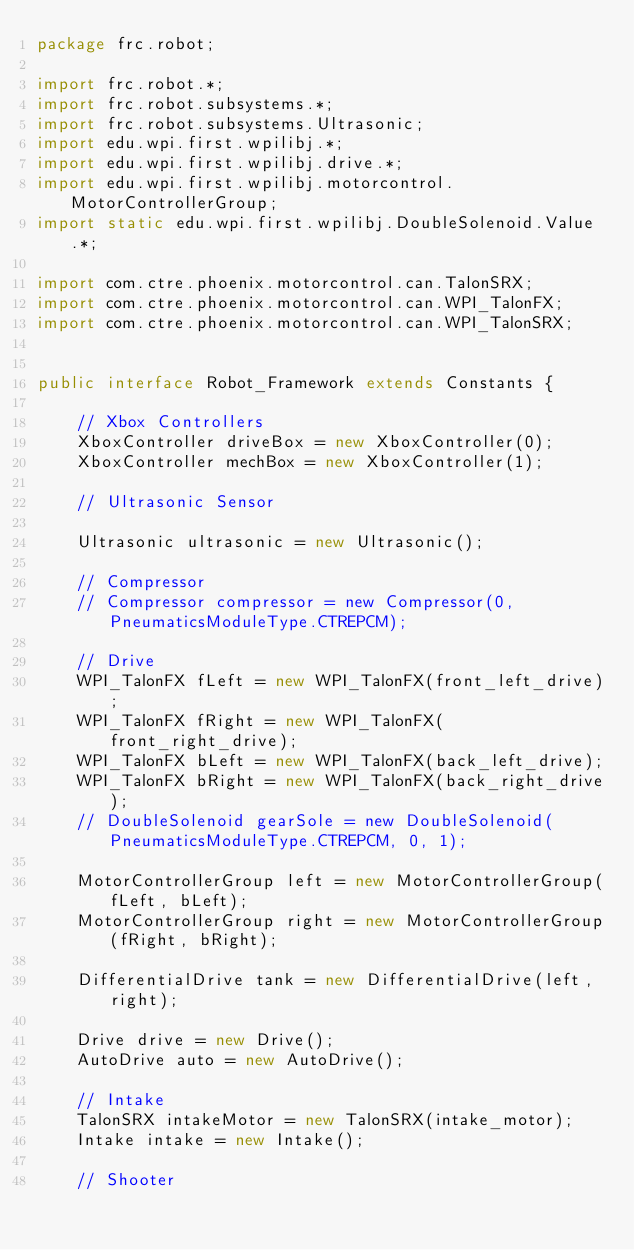Convert code to text. <code><loc_0><loc_0><loc_500><loc_500><_Java_>package frc.robot;

import frc.robot.*;
import frc.robot.subsystems.*;
import frc.robot.subsystems.Ultrasonic;
import edu.wpi.first.wpilibj.*;
import edu.wpi.first.wpilibj.drive.*;
import edu.wpi.first.wpilibj.motorcontrol.MotorControllerGroup;
import static edu.wpi.first.wpilibj.DoubleSolenoid.Value.*;

import com.ctre.phoenix.motorcontrol.can.TalonSRX;
import com.ctre.phoenix.motorcontrol.can.WPI_TalonFX;
import com.ctre.phoenix.motorcontrol.can.WPI_TalonSRX;


public interface Robot_Framework extends Constants {

    // Xbox Controllers
    XboxController driveBox = new XboxController(0);
    XboxController mechBox = new XboxController(1);

    // Ultrasonic Sensor

    Ultrasonic ultrasonic = new Ultrasonic();

    // Compressor
    // Compressor compressor = new Compressor(0, PneumaticsModuleType.CTREPCM);

    // Drive
    WPI_TalonFX fLeft = new WPI_TalonFX(front_left_drive);
    WPI_TalonFX fRight = new WPI_TalonFX(front_right_drive);
    WPI_TalonFX bLeft = new WPI_TalonFX(back_left_drive);
    WPI_TalonFX bRight = new WPI_TalonFX(back_right_drive);
    // DoubleSolenoid gearSole = new DoubleSolenoid(PneumaticsModuleType.CTREPCM, 0, 1);

    MotorControllerGroup left = new MotorControllerGroup(fLeft, bLeft);
    MotorControllerGroup right = new MotorControllerGroup(fRight, bRight);

    DifferentialDrive tank = new DifferentialDrive(left, right);

    Drive drive = new Drive();
    AutoDrive auto = new AutoDrive();

    // Intake
    TalonSRX intakeMotor = new TalonSRX(intake_motor);
    Intake intake = new Intake();

    // Shooter</code> 